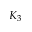Convert formula to latex. <formula><loc_0><loc_0><loc_500><loc_500>K _ { 3 }</formula> 